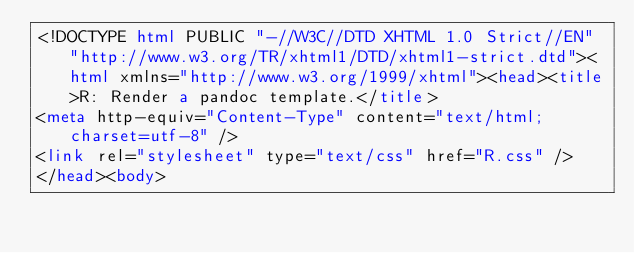<code> <loc_0><loc_0><loc_500><loc_500><_HTML_><!DOCTYPE html PUBLIC "-//W3C//DTD XHTML 1.0 Strict//EN" "http://www.w3.org/TR/xhtml1/DTD/xhtml1-strict.dtd"><html xmlns="http://www.w3.org/1999/xhtml"><head><title>R: Render a pandoc template.</title>
<meta http-equiv="Content-Type" content="text/html; charset=utf-8" />
<link rel="stylesheet" type="text/css" href="R.css" />
</head><body>
</code> 